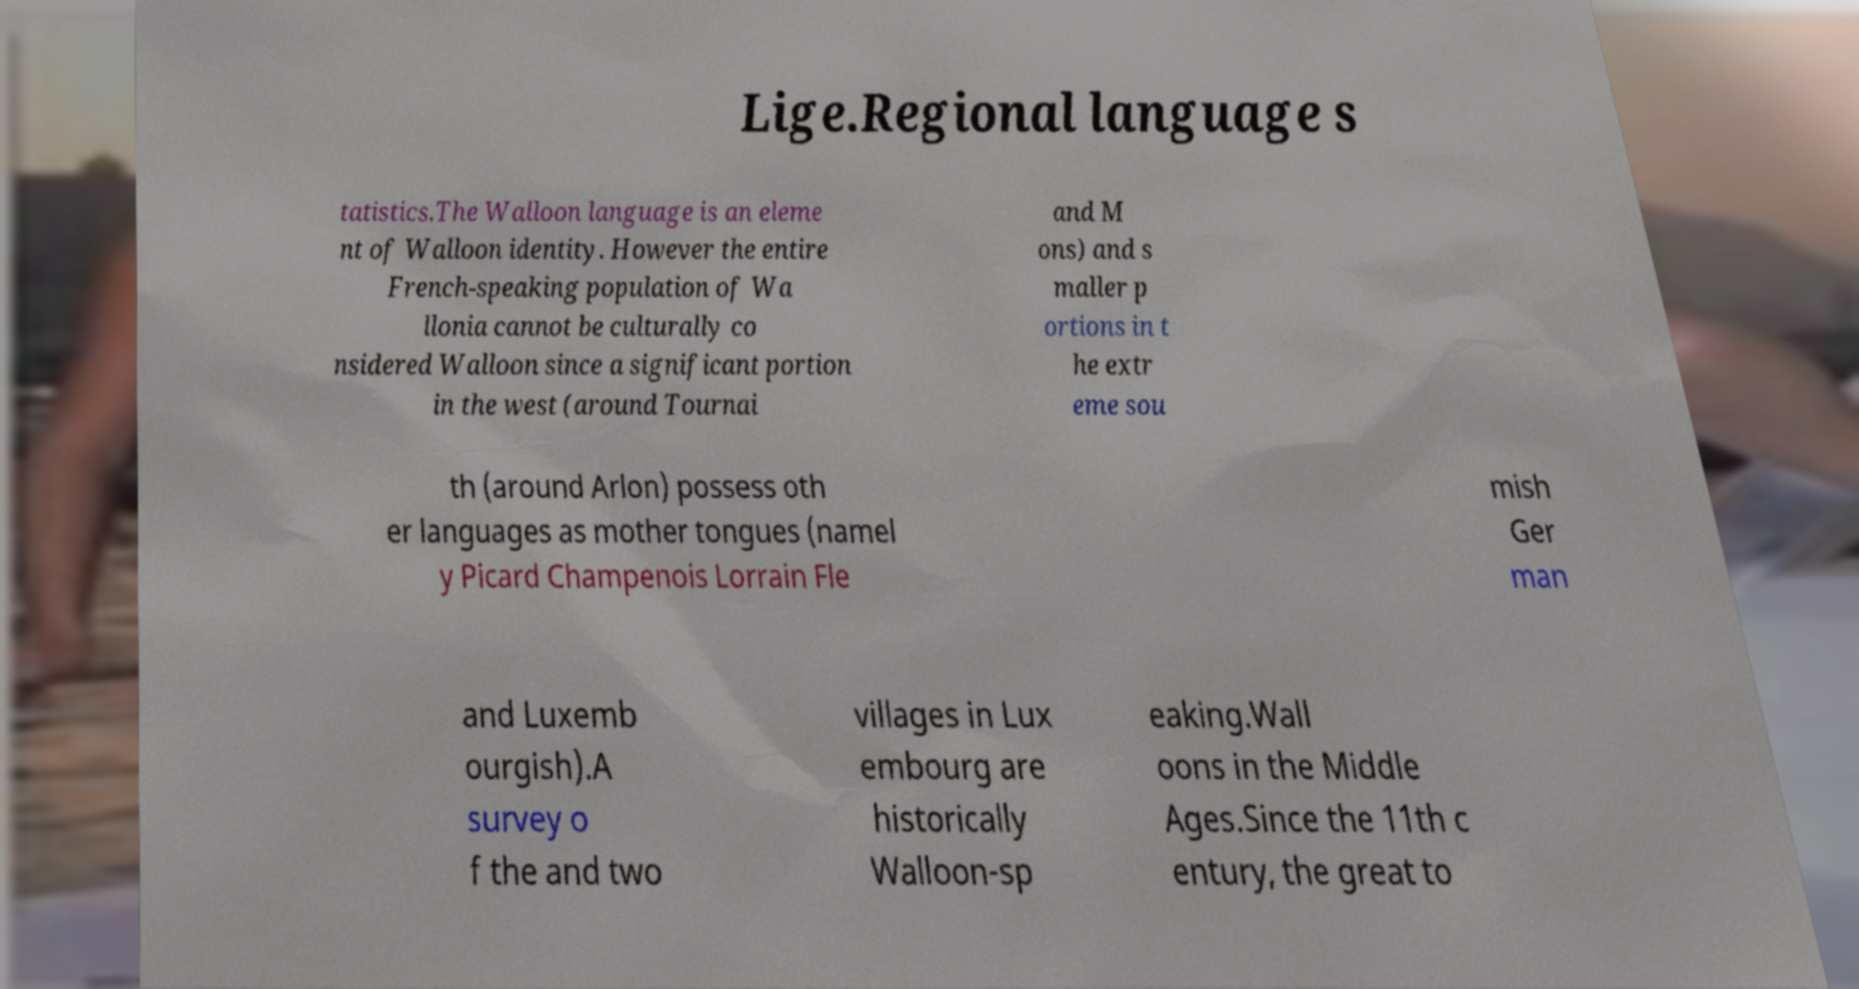Could you assist in decoding the text presented in this image and type it out clearly? Lige.Regional language s tatistics.The Walloon language is an eleme nt of Walloon identity. However the entire French-speaking population of Wa llonia cannot be culturally co nsidered Walloon since a significant portion in the west (around Tournai and M ons) and s maller p ortions in t he extr eme sou th (around Arlon) possess oth er languages as mother tongues (namel y Picard Champenois Lorrain Fle mish Ger man and Luxemb ourgish).A survey o f the and two villages in Lux embourg are historically Walloon-sp eaking.Wall oons in the Middle Ages.Since the 11th c entury, the great to 